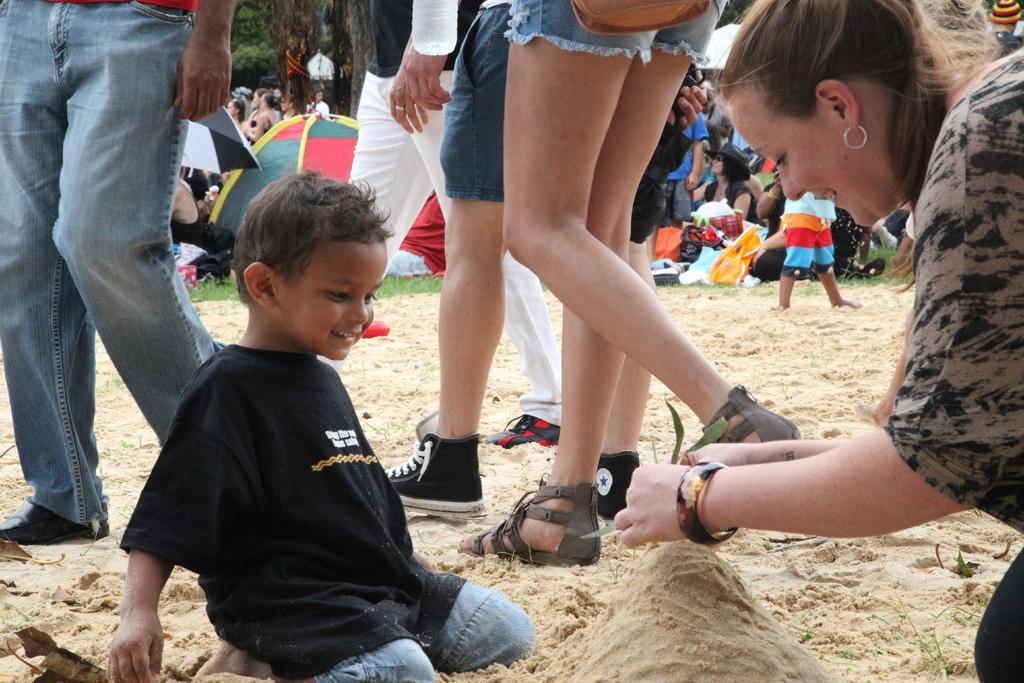Can you describe this image briefly? In the center of the image we can see a lady and a boy sitting on the sand. In the background there are people and we can see tents, umbrella and trees. 